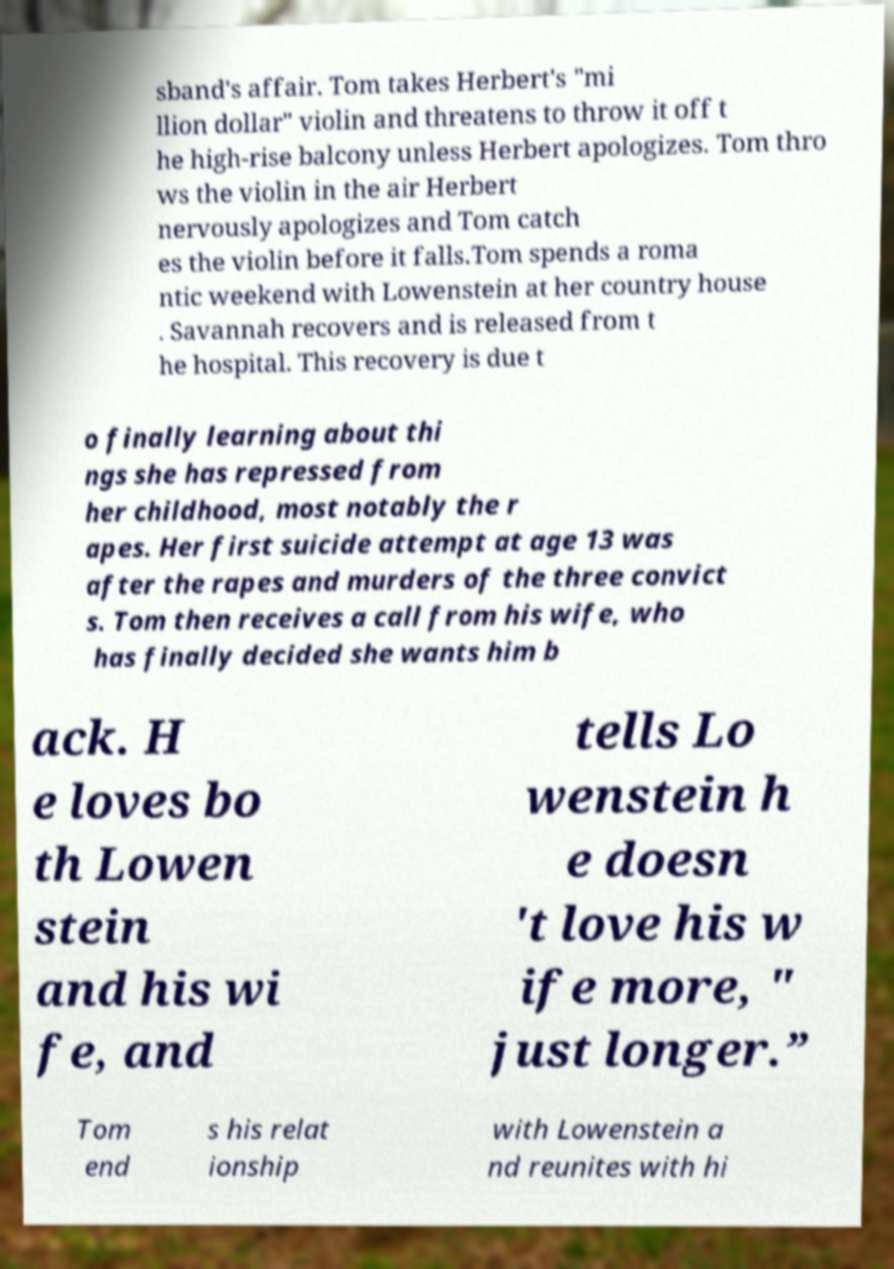Can you accurately transcribe the text from the provided image for me? sband's affair. Tom takes Herbert's "mi llion dollar" violin and threatens to throw it off t he high-rise balcony unless Herbert apologizes. Tom thro ws the violin in the air Herbert nervously apologizes and Tom catch es the violin before it falls.Tom spends a roma ntic weekend with Lowenstein at her country house . Savannah recovers and is released from t he hospital. This recovery is due t o finally learning about thi ngs she has repressed from her childhood, most notably the r apes. Her first suicide attempt at age 13 was after the rapes and murders of the three convict s. Tom then receives a call from his wife, who has finally decided she wants him b ack. H e loves bo th Lowen stein and his wi fe, and tells Lo wenstein h e doesn 't love his w ife more, " just longer.” Tom end s his relat ionship with Lowenstein a nd reunites with hi 